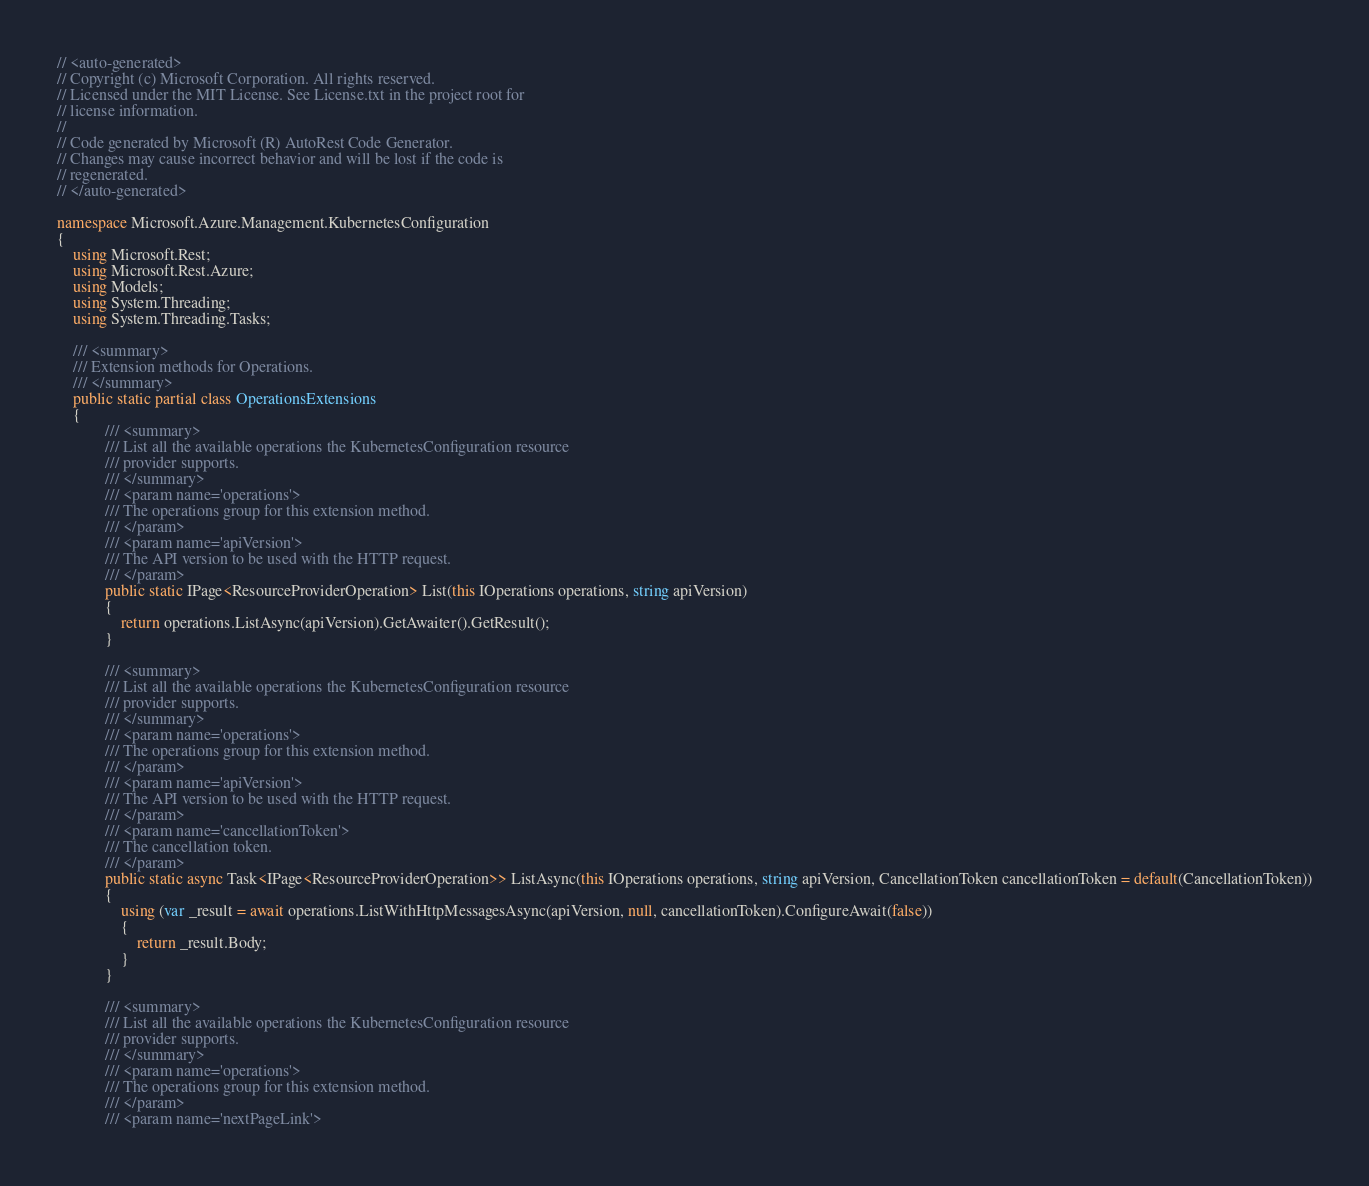<code> <loc_0><loc_0><loc_500><loc_500><_C#_>// <auto-generated>
// Copyright (c) Microsoft Corporation. All rights reserved.
// Licensed under the MIT License. See License.txt in the project root for
// license information.
//
// Code generated by Microsoft (R) AutoRest Code Generator.
// Changes may cause incorrect behavior and will be lost if the code is
// regenerated.
// </auto-generated>

namespace Microsoft.Azure.Management.KubernetesConfiguration
{
    using Microsoft.Rest;
    using Microsoft.Rest.Azure;
    using Models;
    using System.Threading;
    using System.Threading.Tasks;

    /// <summary>
    /// Extension methods for Operations.
    /// </summary>
    public static partial class OperationsExtensions
    {
            /// <summary>
            /// List all the available operations the KubernetesConfiguration resource
            /// provider supports.
            /// </summary>
            /// <param name='operations'>
            /// The operations group for this extension method.
            /// </param>
            /// <param name='apiVersion'>
            /// The API version to be used with the HTTP request.
            /// </param>
            public static IPage<ResourceProviderOperation> List(this IOperations operations, string apiVersion)
            {
                return operations.ListAsync(apiVersion).GetAwaiter().GetResult();
            }

            /// <summary>
            /// List all the available operations the KubernetesConfiguration resource
            /// provider supports.
            /// </summary>
            /// <param name='operations'>
            /// The operations group for this extension method.
            /// </param>
            /// <param name='apiVersion'>
            /// The API version to be used with the HTTP request.
            /// </param>
            /// <param name='cancellationToken'>
            /// The cancellation token.
            /// </param>
            public static async Task<IPage<ResourceProviderOperation>> ListAsync(this IOperations operations, string apiVersion, CancellationToken cancellationToken = default(CancellationToken))
            {
                using (var _result = await operations.ListWithHttpMessagesAsync(apiVersion, null, cancellationToken).ConfigureAwait(false))
                {
                    return _result.Body;
                }
            }

            /// <summary>
            /// List all the available operations the KubernetesConfiguration resource
            /// provider supports.
            /// </summary>
            /// <param name='operations'>
            /// The operations group for this extension method.
            /// </param>
            /// <param name='nextPageLink'></code> 